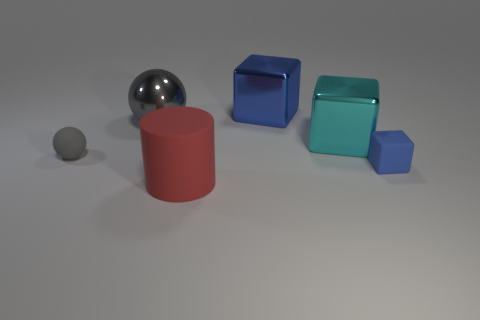Add 4 large red rubber cylinders. How many objects exist? 10 Subtract all spheres. How many objects are left? 4 Add 1 blue cylinders. How many blue cylinders exist? 1 Subtract 0 purple cylinders. How many objects are left? 6 Subtract all cyan blocks. Subtract all large metallic objects. How many objects are left? 2 Add 3 large red objects. How many large red objects are left? 4 